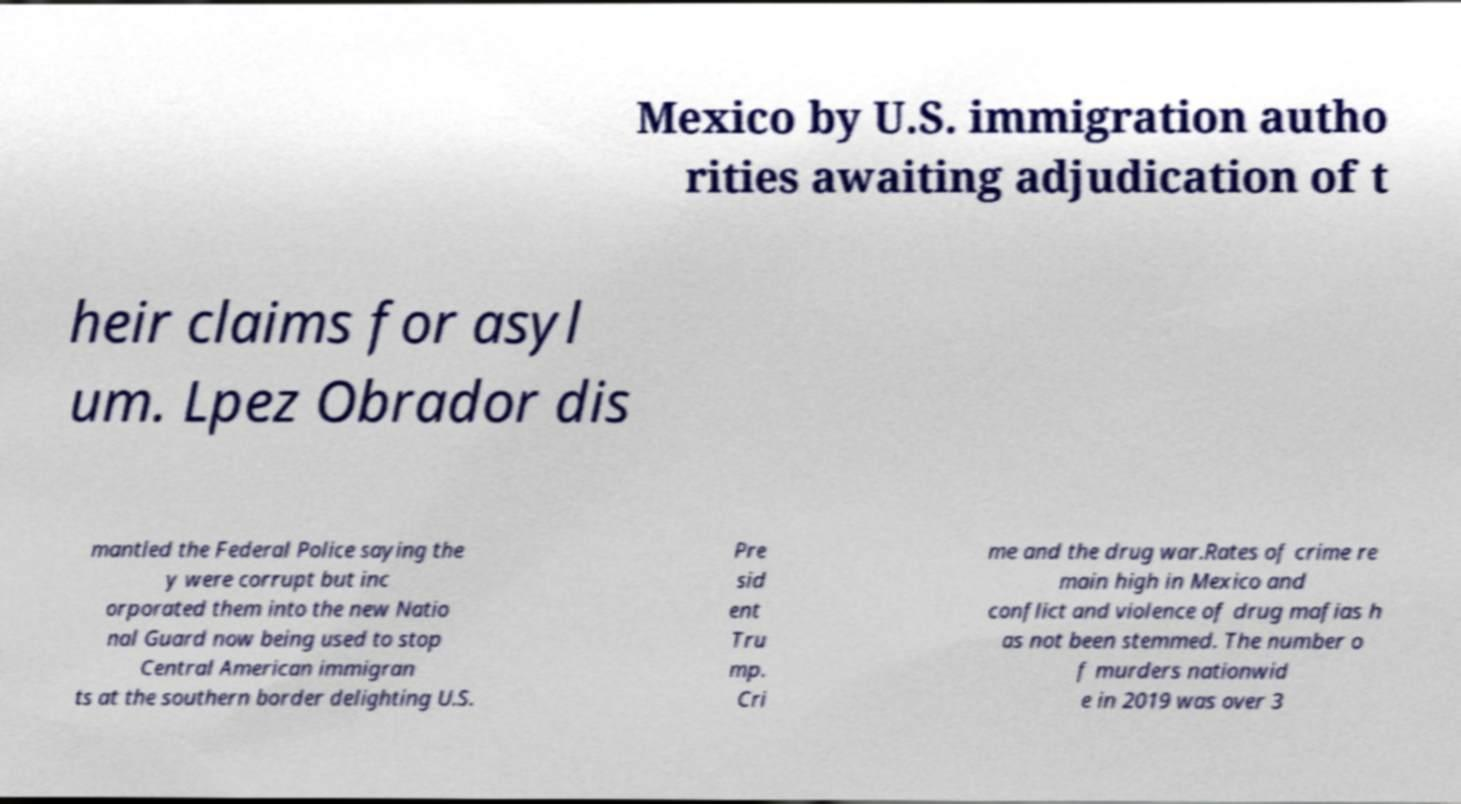For documentation purposes, I need the text within this image transcribed. Could you provide that? Mexico by U.S. immigration autho rities awaiting adjudication of t heir claims for asyl um. Lpez Obrador dis mantled the Federal Police saying the y were corrupt but inc orporated them into the new Natio nal Guard now being used to stop Central American immigran ts at the southern border delighting U.S. Pre sid ent Tru mp. Cri me and the drug war.Rates of crime re main high in Mexico and conflict and violence of drug mafias h as not been stemmed. The number o f murders nationwid e in 2019 was over 3 